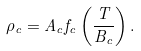Convert formula to latex. <formula><loc_0><loc_0><loc_500><loc_500>\rho _ { c } = A _ { c } f _ { c } \left ( \frac { T } { B _ { c } } \right ) .</formula> 